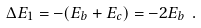Convert formula to latex. <formula><loc_0><loc_0><loc_500><loc_500>\Delta E _ { 1 } = - ( E _ { b } + E _ { c } ) = - 2 E _ { b } \ .</formula> 